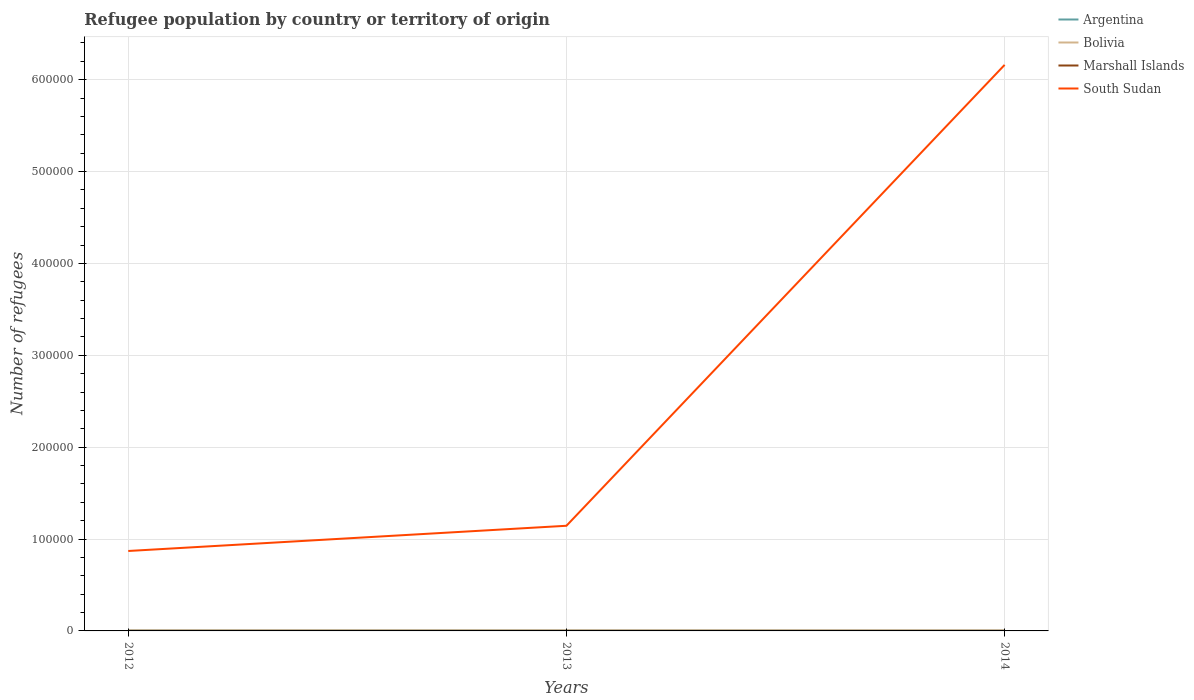Does the line corresponding to South Sudan intersect with the line corresponding to Argentina?
Make the answer very short. No. Is the number of lines equal to the number of legend labels?
Your response must be concise. Yes. Across all years, what is the maximum number of refugees in South Sudan?
Keep it short and to the point. 8.70e+04. In which year was the number of refugees in South Sudan maximum?
Keep it short and to the point. 2012. What is the difference between the highest and the second highest number of refugees in South Sudan?
Make the answer very short. 5.29e+05. What is the difference between the highest and the lowest number of refugees in Marshall Islands?
Provide a succinct answer. 2. Is the number of refugees in Marshall Islands strictly greater than the number of refugees in Argentina over the years?
Your answer should be compact. Yes. How many lines are there?
Provide a succinct answer. 4. How many years are there in the graph?
Offer a terse response. 3. Does the graph contain any zero values?
Keep it short and to the point. No. Does the graph contain grids?
Your response must be concise. Yes. How are the legend labels stacked?
Keep it short and to the point. Vertical. What is the title of the graph?
Your response must be concise. Refugee population by country or territory of origin. Does "St. Kitts and Nevis" appear as one of the legend labels in the graph?
Offer a very short reply. No. What is the label or title of the X-axis?
Ensure brevity in your answer.  Years. What is the label or title of the Y-axis?
Offer a very short reply. Number of refugees. What is the Number of refugees in Argentina in 2012?
Your response must be concise. 447. What is the Number of refugees of Bolivia in 2012?
Give a very brief answer. 618. What is the Number of refugees of Marshall Islands in 2012?
Provide a short and direct response. 2. What is the Number of refugees of South Sudan in 2012?
Your response must be concise. 8.70e+04. What is the Number of refugees of Argentina in 2013?
Keep it short and to the point. 388. What is the Number of refugees in Bolivia in 2013?
Offer a terse response. 601. What is the Number of refugees of Marshall Islands in 2013?
Give a very brief answer. 3. What is the Number of refugees of South Sudan in 2013?
Your answer should be compact. 1.14e+05. What is the Number of refugees of Argentina in 2014?
Offer a very short reply. 318. What is the Number of refugees of Bolivia in 2014?
Make the answer very short. 599. What is the Number of refugees of South Sudan in 2014?
Your answer should be very brief. 6.16e+05. Across all years, what is the maximum Number of refugees of Argentina?
Make the answer very short. 447. Across all years, what is the maximum Number of refugees of Bolivia?
Keep it short and to the point. 618. Across all years, what is the maximum Number of refugees of Marshall Islands?
Give a very brief answer. 3. Across all years, what is the maximum Number of refugees of South Sudan?
Offer a terse response. 6.16e+05. Across all years, what is the minimum Number of refugees in Argentina?
Keep it short and to the point. 318. Across all years, what is the minimum Number of refugees of Bolivia?
Your answer should be very brief. 599. Across all years, what is the minimum Number of refugees of Marshall Islands?
Keep it short and to the point. 2. Across all years, what is the minimum Number of refugees in South Sudan?
Offer a terse response. 8.70e+04. What is the total Number of refugees in Argentina in the graph?
Your answer should be compact. 1153. What is the total Number of refugees in Bolivia in the graph?
Provide a succinct answer. 1818. What is the total Number of refugees of South Sudan in the graph?
Your answer should be very brief. 8.18e+05. What is the difference between the Number of refugees in Bolivia in 2012 and that in 2013?
Ensure brevity in your answer.  17. What is the difference between the Number of refugees in Marshall Islands in 2012 and that in 2013?
Provide a short and direct response. -1. What is the difference between the Number of refugees in South Sudan in 2012 and that in 2013?
Ensure brevity in your answer.  -2.75e+04. What is the difference between the Number of refugees in Argentina in 2012 and that in 2014?
Your response must be concise. 129. What is the difference between the Number of refugees in Marshall Islands in 2012 and that in 2014?
Provide a succinct answer. -1. What is the difference between the Number of refugees of South Sudan in 2012 and that in 2014?
Your answer should be very brief. -5.29e+05. What is the difference between the Number of refugees in Marshall Islands in 2013 and that in 2014?
Give a very brief answer. 0. What is the difference between the Number of refugees in South Sudan in 2013 and that in 2014?
Give a very brief answer. -5.02e+05. What is the difference between the Number of refugees in Argentina in 2012 and the Number of refugees in Bolivia in 2013?
Your response must be concise. -154. What is the difference between the Number of refugees in Argentina in 2012 and the Number of refugees in Marshall Islands in 2013?
Ensure brevity in your answer.  444. What is the difference between the Number of refugees in Argentina in 2012 and the Number of refugees in South Sudan in 2013?
Ensure brevity in your answer.  -1.14e+05. What is the difference between the Number of refugees of Bolivia in 2012 and the Number of refugees of Marshall Islands in 2013?
Offer a very short reply. 615. What is the difference between the Number of refugees of Bolivia in 2012 and the Number of refugees of South Sudan in 2013?
Keep it short and to the point. -1.14e+05. What is the difference between the Number of refugees in Marshall Islands in 2012 and the Number of refugees in South Sudan in 2013?
Offer a terse response. -1.14e+05. What is the difference between the Number of refugees of Argentina in 2012 and the Number of refugees of Bolivia in 2014?
Your answer should be compact. -152. What is the difference between the Number of refugees of Argentina in 2012 and the Number of refugees of Marshall Islands in 2014?
Your answer should be compact. 444. What is the difference between the Number of refugees of Argentina in 2012 and the Number of refugees of South Sudan in 2014?
Make the answer very short. -6.16e+05. What is the difference between the Number of refugees in Bolivia in 2012 and the Number of refugees in Marshall Islands in 2014?
Keep it short and to the point. 615. What is the difference between the Number of refugees of Bolivia in 2012 and the Number of refugees of South Sudan in 2014?
Your answer should be very brief. -6.16e+05. What is the difference between the Number of refugees in Marshall Islands in 2012 and the Number of refugees in South Sudan in 2014?
Ensure brevity in your answer.  -6.16e+05. What is the difference between the Number of refugees of Argentina in 2013 and the Number of refugees of Bolivia in 2014?
Make the answer very short. -211. What is the difference between the Number of refugees in Argentina in 2013 and the Number of refugees in Marshall Islands in 2014?
Your answer should be compact. 385. What is the difference between the Number of refugees in Argentina in 2013 and the Number of refugees in South Sudan in 2014?
Provide a succinct answer. -6.16e+05. What is the difference between the Number of refugees of Bolivia in 2013 and the Number of refugees of Marshall Islands in 2014?
Offer a terse response. 598. What is the difference between the Number of refugees of Bolivia in 2013 and the Number of refugees of South Sudan in 2014?
Your answer should be compact. -6.16e+05. What is the difference between the Number of refugees of Marshall Islands in 2013 and the Number of refugees of South Sudan in 2014?
Provide a succinct answer. -6.16e+05. What is the average Number of refugees in Argentina per year?
Your answer should be very brief. 384.33. What is the average Number of refugees in Bolivia per year?
Give a very brief answer. 606. What is the average Number of refugees in Marshall Islands per year?
Your response must be concise. 2.67. What is the average Number of refugees in South Sudan per year?
Offer a terse response. 2.73e+05. In the year 2012, what is the difference between the Number of refugees in Argentina and Number of refugees in Bolivia?
Offer a very short reply. -171. In the year 2012, what is the difference between the Number of refugees of Argentina and Number of refugees of Marshall Islands?
Keep it short and to the point. 445. In the year 2012, what is the difference between the Number of refugees in Argentina and Number of refugees in South Sudan?
Your response must be concise. -8.66e+04. In the year 2012, what is the difference between the Number of refugees in Bolivia and Number of refugees in Marshall Islands?
Your response must be concise. 616. In the year 2012, what is the difference between the Number of refugees in Bolivia and Number of refugees in South Sudan?
Give a very brief answer. -8.64e+04. In the year 2012, what is the difference between the Number of refugees in Marshall Islands and Number of refugees in South Sudan?
Your answer should be compact. -8.70e+04. In the year 2013, what is the difference between the Number of refugees in Argentina and Number of refugees in Bolivia?
Make the answer very short. -213. In the year 2013, what is the difference between the Number of refugees in Argentina and Number of refugees in Marshall Islands?
Ensure brevity in your answer.  385. In the year 2013, what is the difference between the Number of refugees in Argentina and Number of refugees in South Sudan?
Offer a very short reply. -1.14e+05. In the year 2013, what is the difference between the Number of refugees in Bolivia and Number of refugees in Marshall Islands?
Provide a short and direct response. 598. In the year 2013, what is the difference between the Number of refugees in Bolivia and Number of refugees in South Sudan?
Offer a terse response. -1.14e+05. In the year 2013, what is the difference between the Number of refugees of Marshall Islands and Number of refugees of South Sudan?
Your answer should be compact. -1.14e+05. In the year 2014, what is the difference between the Number of refugees in Argentina and Number of refugees in Bolivia?
Provide a succinct answer. -281. In the year 2014, what is the difference between the Number of refugees of Argentina and Number of refugees of Marshall Islands?
Ensure brevity in your answer.  315. In the year 2014, what is the difference between the Number of refugees of Argentina and Number of refugees of South Sudan?
Give a very brief answer. -6.16e+05. In the year 2014, what is the difference between the Number of refugees in Bolivia and Number of refugees in Marshall Islands?
Offer a terse response. 596. In the year 2014, what is the difference between the Number of refugees in Bolivia and Number of refugees in South Sudan?
Give a very brief answer. -6.16e+05. In the year 2014, what is the difference between the Number of refugees in Marshall Islands and Number of refugees in South Sudan?
Ensure brevity in your answer.  -6.16e+05. What is the ratio of the Number of refugees of Argentina in 2012 to that in 2013?
Provide a succinct answer. 1.15. What is the ratio of the Number of refugees of Bolivia in 2012 to that in 2013?
Offer a very short reply. 1.03. What is the ratio of the Number of refugees in South Sudan in 2012 to that in 2013?
Keep it short and to the point. 0.76. What is the ratio of the Number of refugees of Argentina in 2012 to that in 2014?
Your answer should be very brief. 1.41. What is the ratio of the Number of refugees of Bolivia in 2012 to that in 2014?
Provide a succinct answer. 1.03. What is the ratio of the Number of refugees of South Sudan in 2012 to that in 2014?
Offer a terse response. 0.14. What is the ratio of the Number of refugees of Argentina in 2013 to that in 2014?
Your response must be concise. 1.22. What is the ratio of the Number of refugees in South Sudan in 2013 to that in 2014?
Ensure brevity in your answer.  0.19. What is the difference between the highest and the second highest Number of refugees of Bolivia?
Offer a very short reply. 17. What is the difference between the highest and the second highest Number of refugees of South Sudan?
Keep it short and to the point. 5.02e+05. What is the difference between the highest and the lowest Number of refugees of Argentina?
Provide a short and direct response. 129. What is the difference between the highest and the lowest Number of refugees in Marshall Islands?
Offer a terse response. 1. What is the difference between the highest and the lowest Number of refugees in South Sudan?
Give a very brief answer. 5.29e+05. 